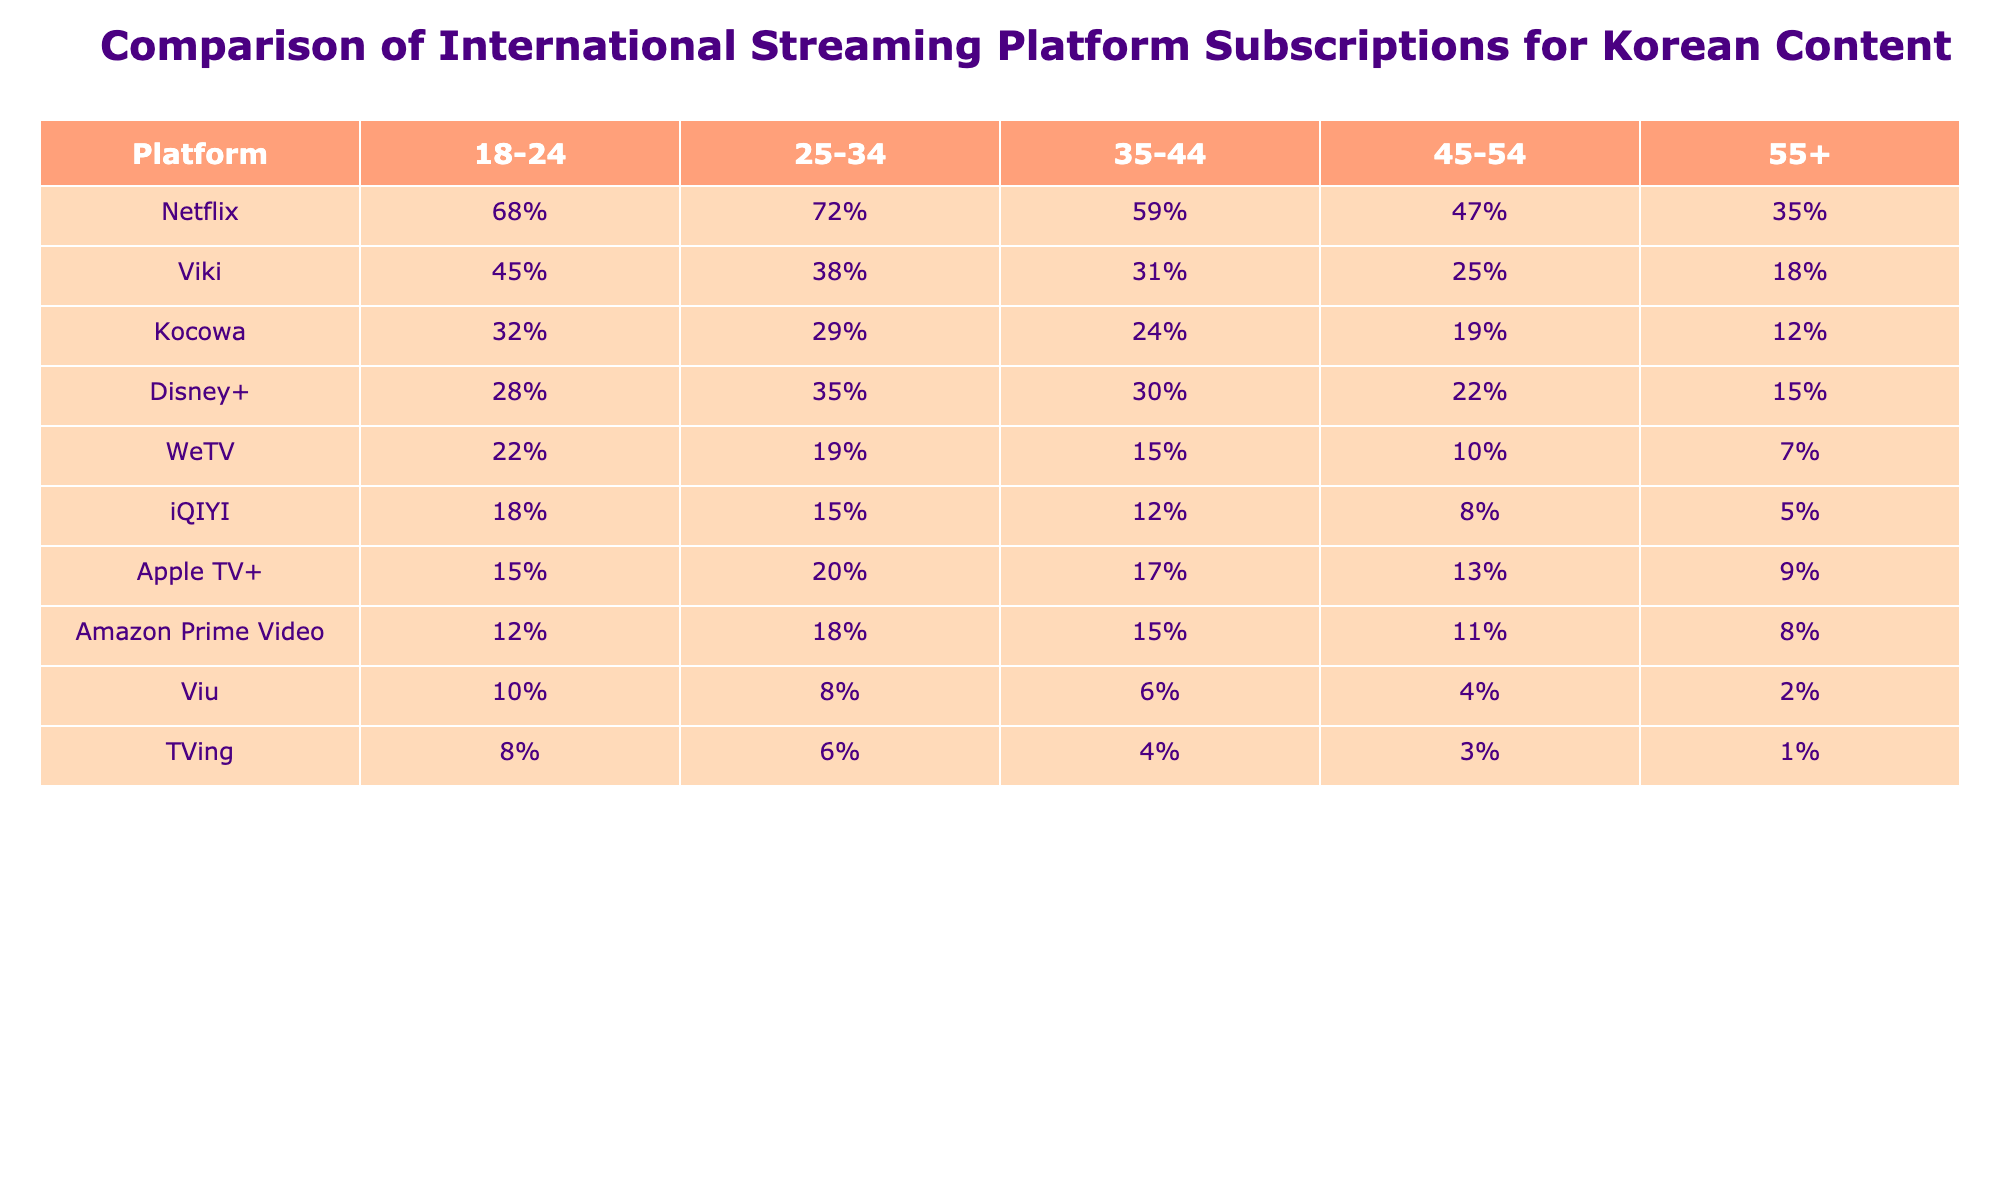What is the subscription rate for Netflix among the 25-34 age group? According to the table, Netflix has a subscription rate of 72% for the 25-34 age group.
Answer: 72% Which platform has the highest subscription rate in the 18-24 age group? The table indicates that Netflix has the highest subscription rate in the 18-24 age group at 68%.
Answer: Netflix What is the difference in subscription rates between Disney+ and Kocowa for the 35-44 age group? For Disney+, the subscription rate is 30%, while for Kocowa it is 24%. The difference is calculated as 30% - 24% = 6%.
Answer: 6% Is the subscription rate for Viki higher than for TVing in the 45-54 age group? In the 45-54 age group, Viki has a subscription rate of 25%, while TVing has a rate of 3%. Since 25% is greater than 3%, the statement is true.
Answer: Yes What is the average subscription rate across all platforms for the 55+ age group? To find the average, sum the subscription rates for the 55+ age group: 35% (Netflix) + 18% (Viki) + 12% (Kocowa) + 15% (Disney+) + 7% (WeTV) + 5% (iQIYI) + 9% (Apple TV+) + 8% (Amazon Prime Video) + 2% (Viu) + 1% (TVing) = 112%. There are 10 platforms, so the average is 112% / 10 = 11.2%.
Answer: 11.2% Which age group has the lowest subscription rates for all listed platforms? By inspecting the table, it is clear that the 55+ age group has the lowest subscription rates across all platforms when comparing the percentages given.
Answer: 55+ Is the subscription rate for WeTV in the 35-44 age group greater than that of iQIYI in any age group? WeTV has a rate of 15% in the 35-44 age group, while iQIYI only has rates less than this in all age groups: 12% (35-44), 8% (45-54), and 5% (55+). Therefore, WeTV's rate is indeed greater than iQIYI in every age group presented.
Answer: Yes 